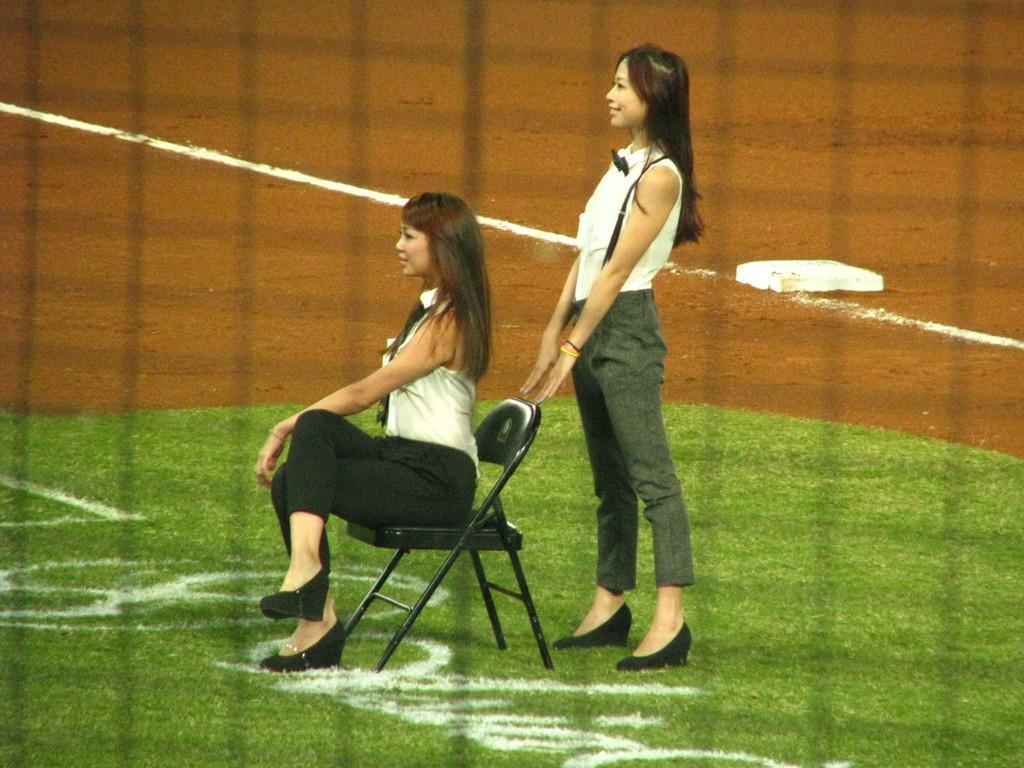Describe this image in one or two sentences. In this image I can see two women among them, one is sitting on a chair and other is standing on the ground. 